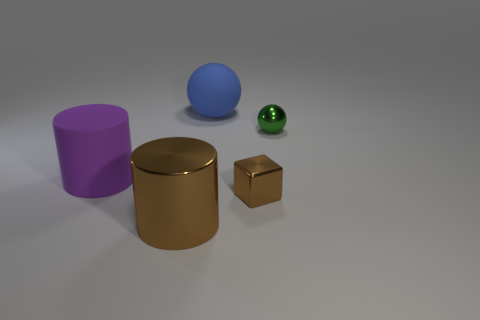Add 3 small shiny balls. How many objects exist? 8 Subtract all cylinders. How many objects are left? 3 Add 4 blue matte cubes. How many blue matte cubes exist? 4 Subtract 0 brown spheres. How many objects are left? 5 Subtract all purple shiny blocks. Subtract all shiny cylinders. How many objects are left? 4 Add 4 large blue things. How many large blue things are left? 5 